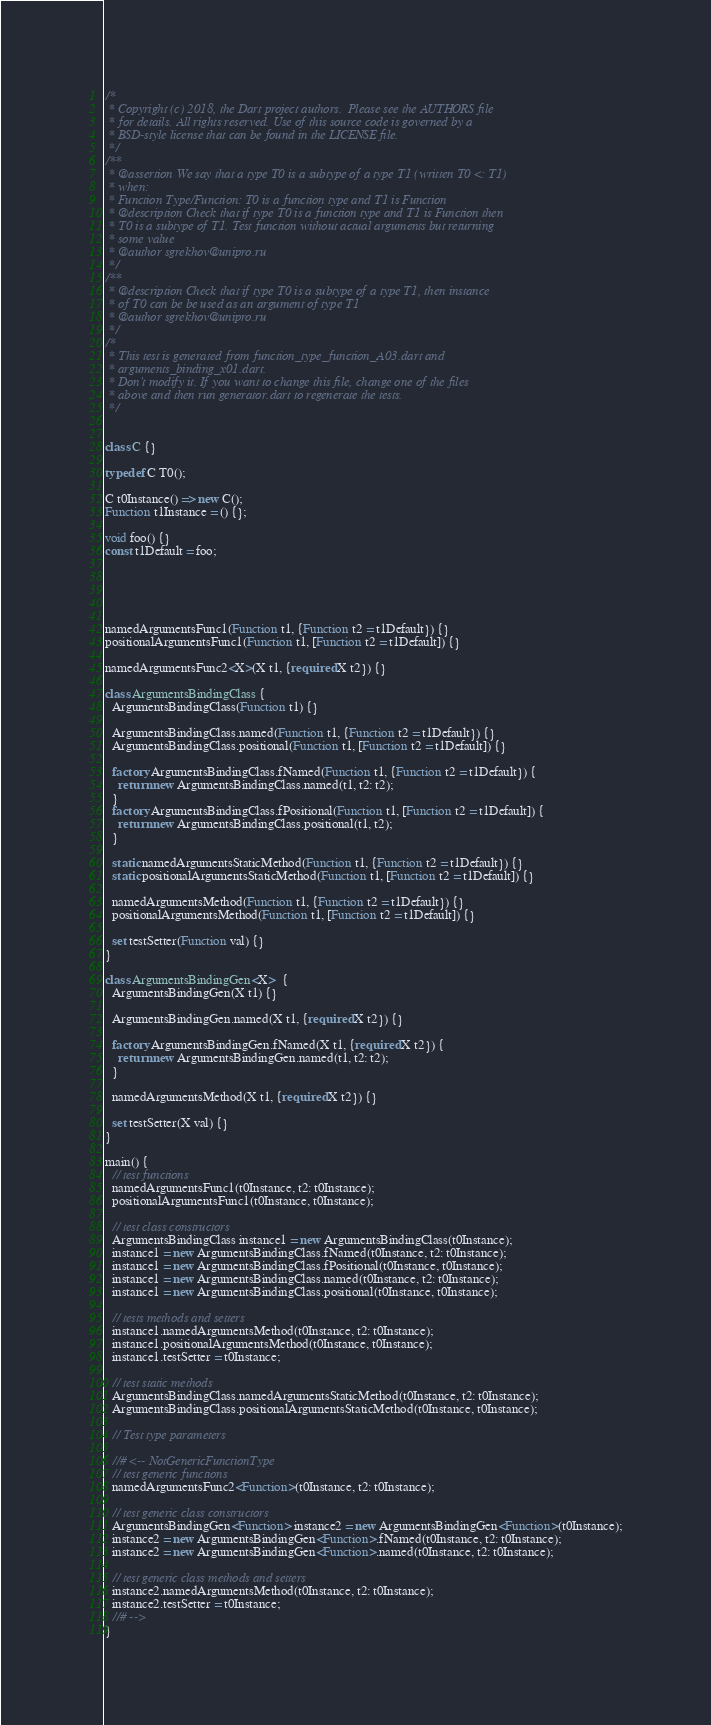<code> <loc_0><loc_0><loc_500><loc_500><_Dart_>/*
 * Copyright (c) 2018, the Dart project authors.  Please see the AUTHORS file
 * for details. All rights reserved. Use of this source code is governed by a
 * BSD-style license that can be found in the LICENSE file.
 */
/**
 * @assertion We say that a type T0 is a subtype of a type T1 (written T0 <: T1)
 * when:
 * Function Type/Function: T0 is a function type and T1 is Function
 * @description Check that if type T0 is a function type and T1 is Function then
 * T0 is a subtype of T1. Test function without actual arguments but returning
 * some value
 * @author sgrekhov@unipro.ru
 */
/**
 * @description Check that if type T0 is a subtype of a type T1, then instance
 * of T0 can be be used as an argument of type T1
 * @author sgrekhov@unipro.ru
 */
/*
 * This test is generated from function_type_function_A03.dart and 
 * arguments_binding_x01.dart.
 * Don't modify it. If you want to change this file, change one of the files 
 * above and then run generator.dart to regenerate the tests.
 */


class C {}

typedef C T0();

C t0Instance() => new C();
Function t1Instance = () {};

void foo() {}
const t1Default = foo;





namedArgumentsFunc1(Function t1, {Function t2 = t1Default}) {}
positionalArgumentsFunc1(Function t1, [Function t2 = t1Default]) {}

namedArgumentsFunc2<X>(X t1, {required X t2}) {}

class ArgumentsBindingClass {
  ArgumentsBindingClass(Function t1) {}

  ArgumentsBindingClass.named(Function t1, {Function t2 = t1Default}) {}
  ArgumentsBindingClass.positional(Function t1, [Function t2 = t1Default]) {}

  factory ArgumentsBindingClass.fNamed(Function t1, {Function t2 = t1Default}) {
    return new ArgumentsBindingClass.named(t1, t2: t2);
  }
  factory ArgumentsBindingClass.fPositional(Function t1, [Function t2 = t1Default]) {
    return new ArgumentsBindingClass.positional(t1, t2);
  }

  static namedArgumentsStaticMethod(Function t1, {Function t2 = t1Default}) {}
  static positionalArgumentsStaticMethod(Function t1, [Function t2 = t1Default]) {}

  namedArgumentsMethod(Function t1, {Function t2 = t1Default}) {}
  positionalArgumentsMethod(Function t1, [Function t2 = t1Default]) {}

  set testSetter(Function val) {}
}

class ArgumentsBindingGen<X>  {
  ArgumentsBindingGen(X t1) {}

  ArgumentsBindingGen.named(X t1, {required X t2}) {}

  factory ArgumentsBindingGen.fNamed(X t1, {required X t2}) {
    return new ArgumentsBindingGen.named(t1, t2: t2);
  }

  namedArgumentsMethod(X t1, {required X t2}) {}

  set testSetter(X val) {}
}

main() {
  // test functions
  namedArgumentsFunc1(t0Instance, t2: t0Instance);
  positionalArgumentsFunc1(t0Instance, t0Instance);

  // test class constructors
  ArgumentsBindingClass instance1 = new ArgumentsBindingClass(t0Instance);
  instance1 = new ArgumentsBindingClass.fNamed(t0Instance, t2: t0Instance);
  instance1 = new ArgumentsBindingClass.fPositional(t0Instance, t0Instance);
  instance1 = new ArgumentsBindingClass.named(t0Instance, t2: t0Instance);
  instance1 = new ArgumentsBindingClass.positional(t0Instance, t0Instance);

  // tests methods and setters
  instance1.namedArgumentsMethod(t0Instance, t2: t0Instance);
  instance1.positionalArgumentsMethod(t0Instance, t0Instance);
  instance1.testSetter = t0Instance;

  // test static methods
  ArgumentsBindingClass.namedArgumentsStaticMethod(t0Instance, t2: t0Instance);
  ArgumentsBindingClass.positionalArgumentsStaticMethod(t0Instance, t0Instance);

  // Test type parameters

  //# <-- NotGenericFunctionType
  // test generic functions
  namedArgumentsFunc2<Function>(t0Instance, t2: t0Instance);

  // test generic class constructors
  ArgumentsBindingGen<Function> instance2 = new ArgumentsBindingGen<Function>(t0Instance);
  instance2 = new ArgumentsBindingGen<Function>.fNamed(t0Instance, t2: t0Instance);
  instance2 = new ArgumentsBindingGen<Function>.named(t0Instance, t2: t0Instance);

  // test generic class methods and setters
  instance2.namedArgumentsMethod(t0Instance, t2: t0Instance);
  instance2.testSetter = t0Instance;
  //# -->
}
</code> 